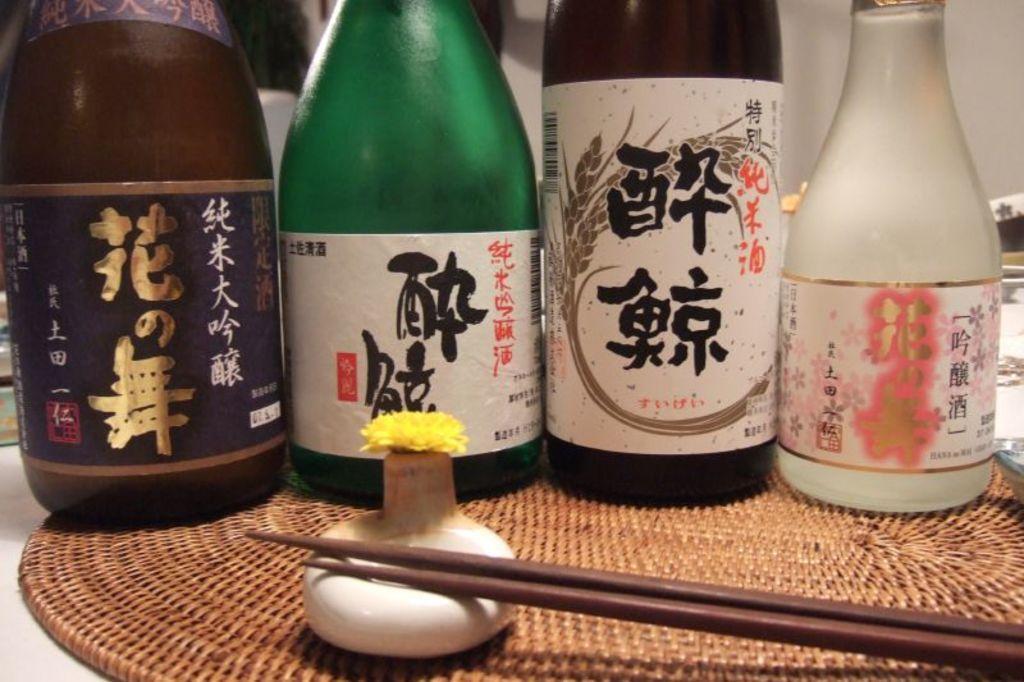Could you give a brief overview of what you see in this image? In this image there is a table and we can see chopsticks, decor, bottles and a table coaster placed on the table. In the background there is a wall. 